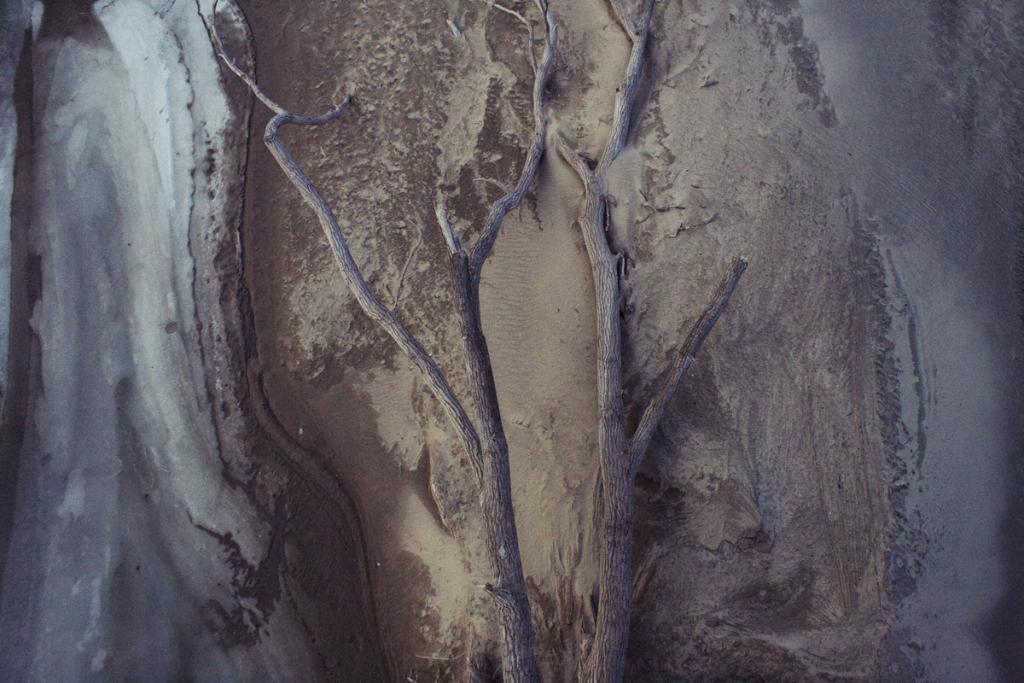How would you summarize this image in a sentence or two? In this image I can see a tree which is brown in color is fallen on the sand. To the left side of the image I can see the mud which is brown and white in color. 